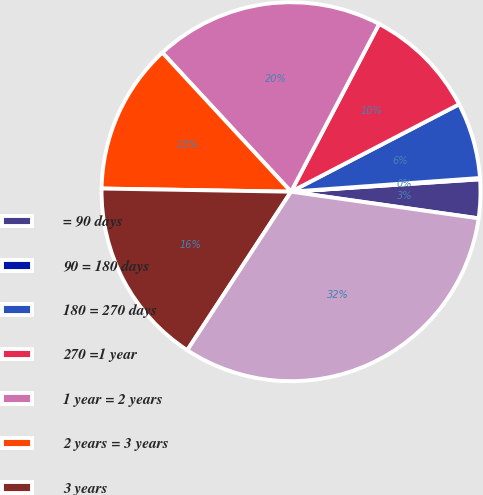Convert chart to OTSL. <chart><loc_0><loc_0><loc_500><loc_500><pie_chart><fcel>= 90 days<fcel>90 = 180 days<fcel>180 = 270 days<fcel>270 =1 year<fcel>1 year = 2 years<fcel>2 years = 3 years<fcel>3 years<fcel>Total<nl><fcel>3.29%<fcel>0.11%<fcel>6.48%<fcel>9.67%<fcel>19.58%<fcel>12.85%<fcel>16.04%<fcel>31.98%<nl></chart> 